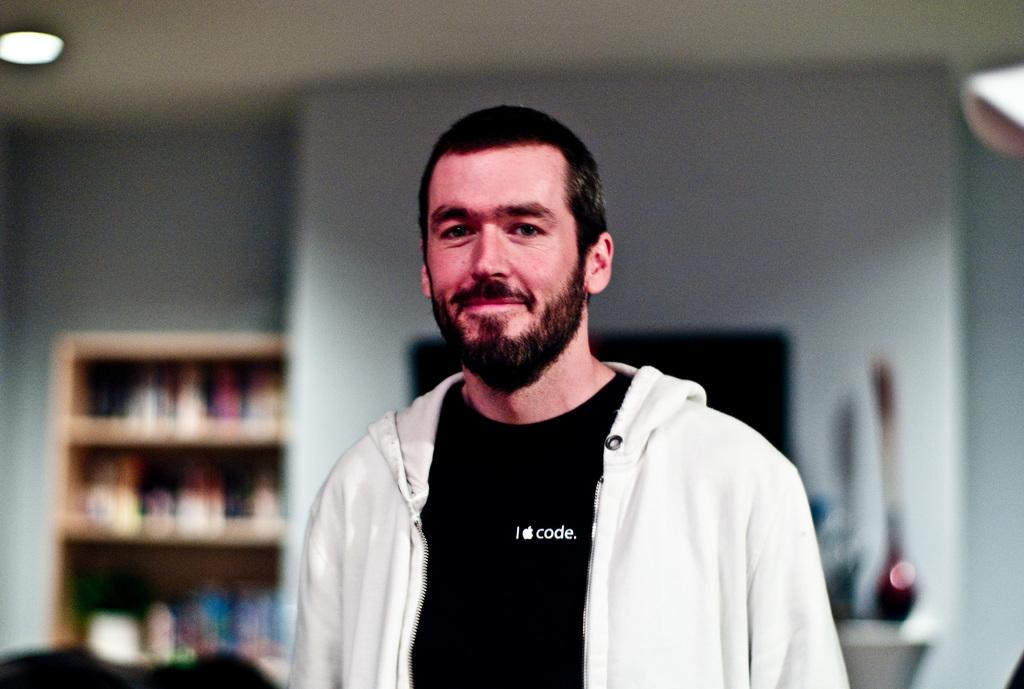Provide a one-sentence caption for the provided image. A man wearing a white hoodie and a black T-shirt with the Apple logo which indicates he might be an employee. 